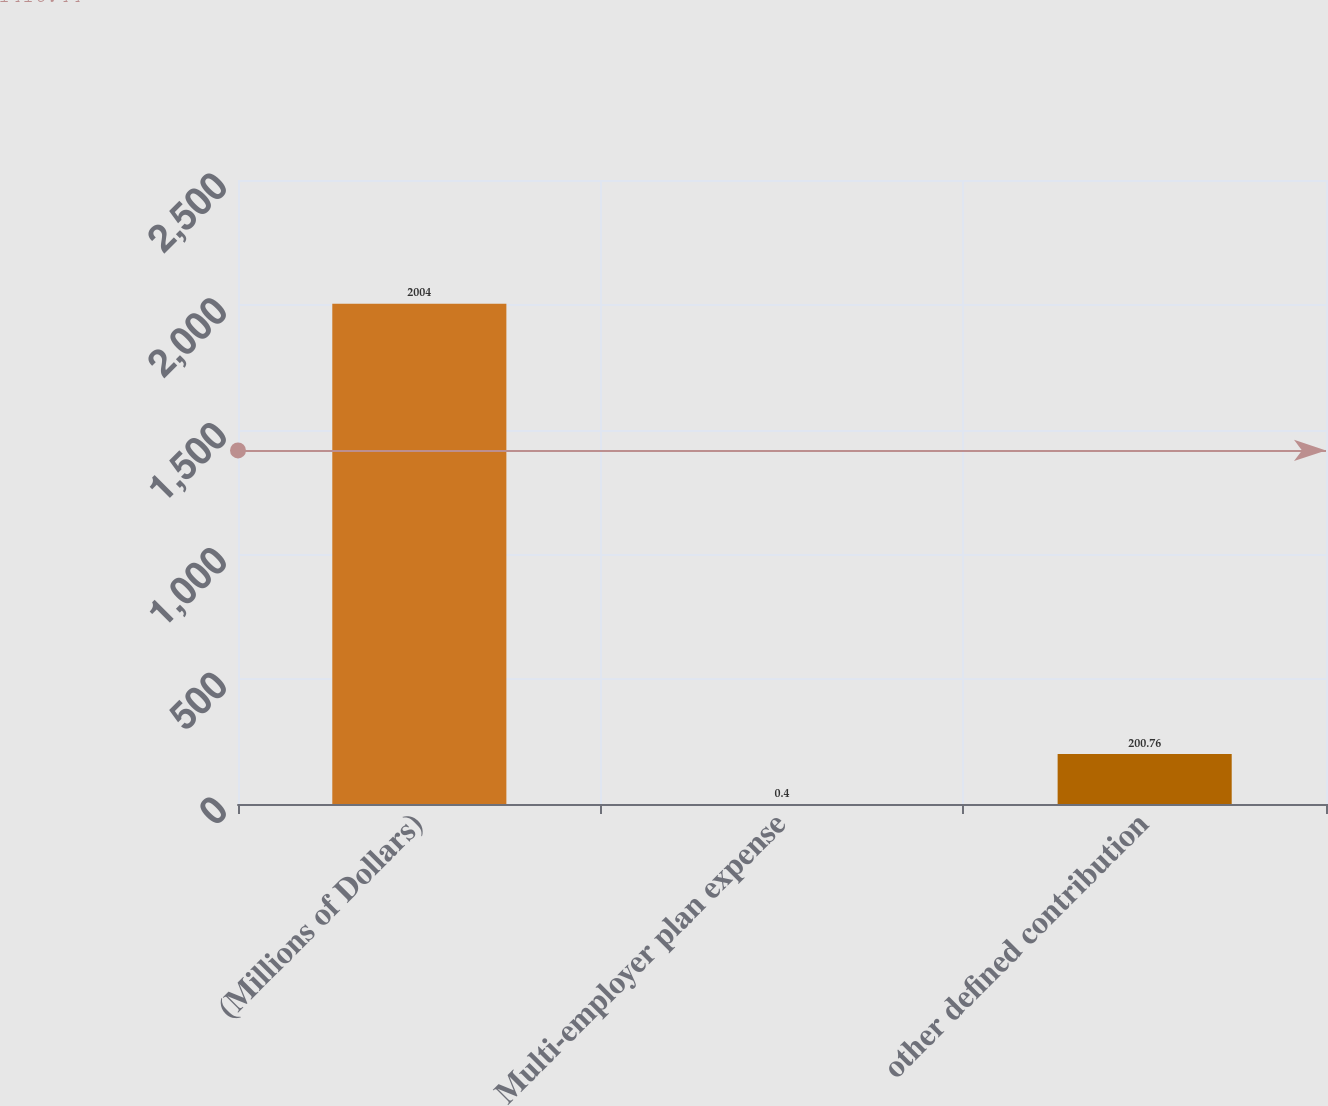Convert chart. <chart><loc_0><loc_0><loc_500><loc_500><bar_chart><fcel>(Millions of Dollars)<fcel>Multi-employer plan expense<fcel>other defined contribution<nl><fcel>2004<fcel>0.4<fcel>200.76<nl></chart> 